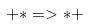<formula> <loc_0><loc_0><loc_500><loc_500>+ * = > * +</formula> 